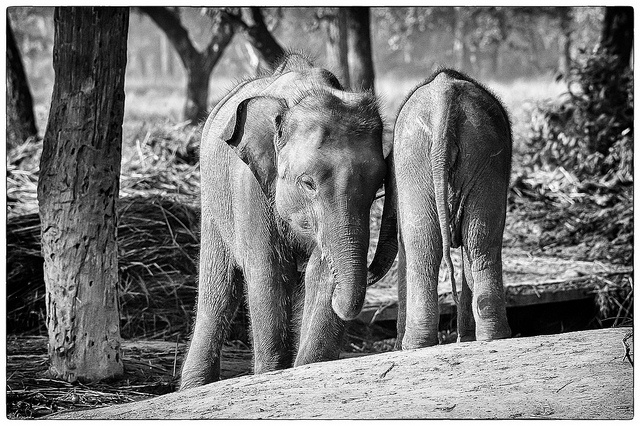Describe the objects in this image and their specific colors. I can see elephant in white, darkgray, lightgray, gray, and black tones and elephant in white, black, gray, lightgray, and darkgray tones in this image. 